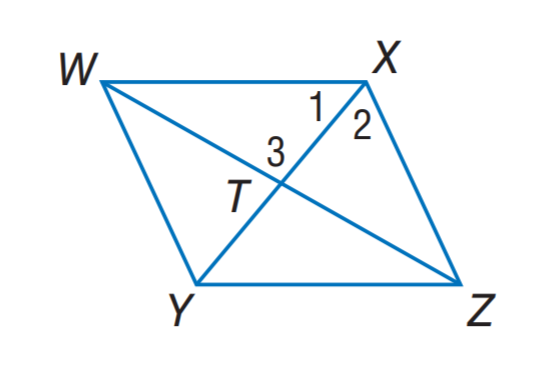Question: Quadrilateral W X Z Y is a rhombus. If m \angle X Z Y = 56, find m \angle Y W Z.
Choices:
A. 14
B. 28
C. 34
D. 56
Answer with the letter. Answer: B 